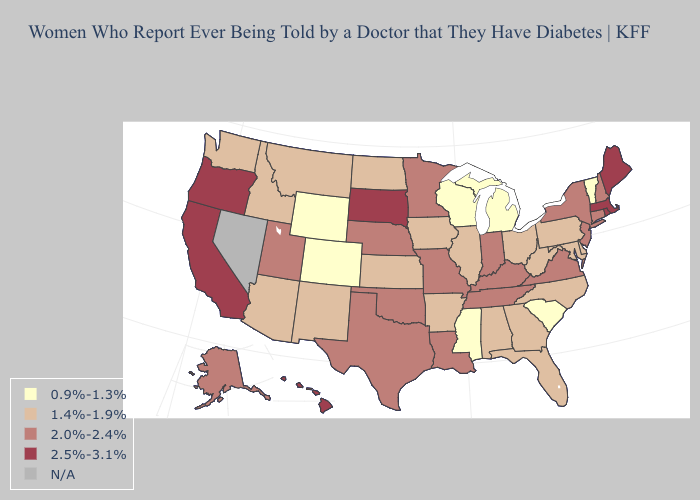Among the states that border Ohio , does Michigan have the lowest value?
Give a very brief answer. Yes. Name the states that have a value in the range 1.4%-1.9%?
Answer briefly. Alabama, Arizona, Arkansas, Delaware, Florida, Georgia, Idaho, Illinois, Iowa, Kansas, Maryland, Montana, New Mexico, North Carolina, North Dakota, Ohio, Pennsylvania, Washington, West Virginia. Name the states that have a value in the range N/A?
Answer briefly. Nevada. What is the value of Montana?
Short answer required. 1.4%-1.9%. Does Tennessee have the highest value in the South?
Short answer required. Yes. Name the states that have a value in the range 0.9%-1.3%?
Quick response, please. Colorado, Michigan, Mississippi, South Carolina, Vermont, Wisconsin, Wyoming. Name the states that have a value in the range 1.4%-1.9%?
Write a very short answer. Alabama, Arizona, Arkansas, Delaware, Florida, Georgia, Idaho, Illinois, Iowa, Kansas, Maryland, Montana, New Mexico, North Carolina, North Dakota, Ohio, Pennsylvania, Washington, West Virginia. Among the states that border Mississippi , which have the highest value?
Answer briefly. Louisiana, Tennessee. What is the highest value in the South ?
Quick response, please. 2.0%-2.4%. Name the states that have a value in the range 0.9%-1.3%?
Quick response, please. Colorado, Michigan, Mississippi, South Carolina, Vermont, Wisconsin, Wyoming. What is the value of Ohio?
Short answer required. 1.4%-1.9%. What is the lowest value in the South?
Short answer required. 0.9%-1.3%. What is the value of Kansas?
Short answer required. 1.4%-1.9%. 